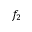<formula> <loc_0><loc_0><loc_500><loc_500>f _ { 2 }</formula> 